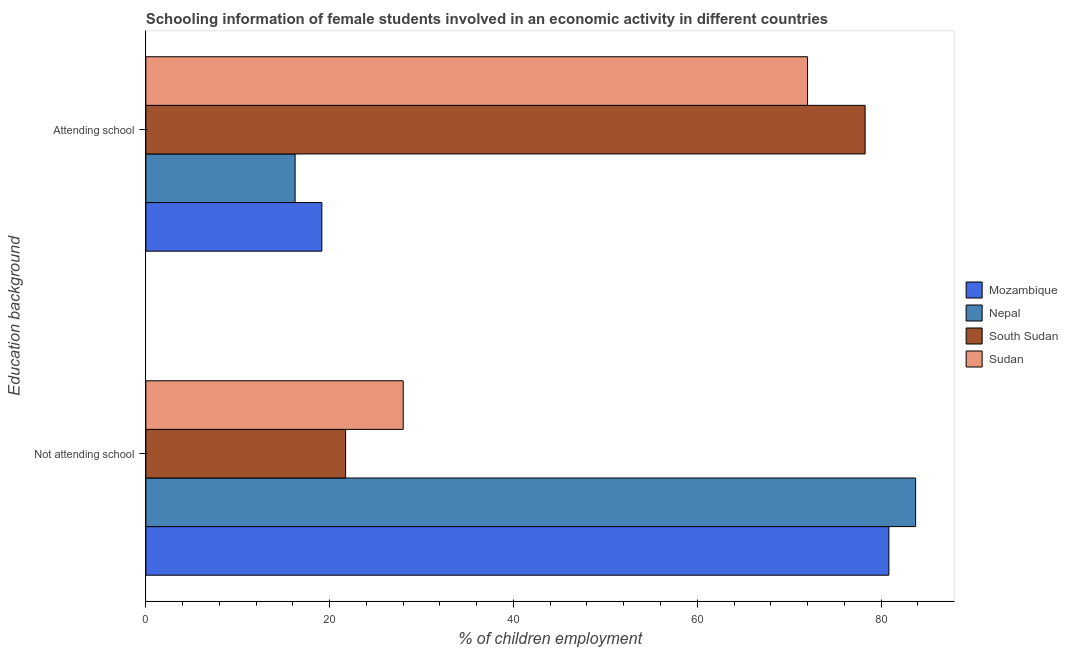How many different coloured bars are there?
Your answer should be compact. 4. How many groups of bars are there?
Keep it short and to the point. 2. Are the number of bars on each tick of the Y-axis equal?
Keep it short and to the point. Yes. How many bars are there on the 2nd tick from the bottom?
Ensure brevity in your answer.  4. What is the label of the 2nd group of bars from the top?
Provide a short and direct response. Not attending school. What is the percentage of employed females who are attending school in Mozambique?
Provide a succinct answer. 19.15. Across all countries, what is the maximum percentage of employed females who are not attending school?
Keep it short and to the point. 83.76. Across all countries, what is the minimum percentage of employed females who are not attending school?
Your answer should be compact. 21.74. In which country was the percentage of employed females who are not attending school maximum?
Offer a terse response. Nepal. In which country was the percentage of employed females who are attending school minimum?
Offer a very short reply. Nepal. What is the total percentage of employed females who are attending school in the graph?
Your answer should be compact. 185.65. What is the difference between the percentage of employed females who are attending school in Mozambique and that in Sudan?
Give a very brief answer. -52.85. What is the difference between the percentage of employed females who are not attending school in Mozambique and the percentage of employed females who are attending school in South Sudan?
Your answer should be compact. 2.59. What is the average percentage of employed females who are attending school per country?
Your answer should be compact. 46.41. What is the difference between the percentage of employed females who are attending school and percentage of employed females who are not attending school in Nepal?
Offer a terse response. -67.52. In how many countries, is the percentage of employed females who are attending school greater than 36 %?
Ensure brevity in your answer.  2. What is the ratio of the percentage of employed females who are attending school in Sudan to that in Mozambique?
Offer a very short reply. 3.76. Is the percentage of employed females who are attending school in Sudan less than that in South Sudan?
Provide a succinct answer. Yes. In how many countries, is the percentage of employed females who are attending school greater than the average percentage of employed females who are attending school taken over all countries?
Provide a short and direct response. 2. What does the 2nd bar from the top in Attending school represents?
Provide a succinct answer. South Sudan. What does the 3rd bar from the bottom in Attending school represents?
Offer a terse response. South Sudan. How many bars are there?
Offer a terse response. 8. What is the difference between two consecutive major ticks on the X-axis?
Give a very brief answer. 20. Are the values on the major ticks of X-axis written in scientific E-notation?
Your response must be concise. No. How many legend labels are there?
Offer a very short reply. 4. How are the legend labels stacked?
Ensure brevity in your answer.  Vertical. What is the title of the graph?
Your answer should be very brief. Schooling information of female students involved in an economic activity in different countries. What is the label or title of the X-axis?
Give a very brief answer. % of children employment. What is the label or title of the Y-axis?
Ensure brevity in your answer.  Education background. What is the % of children employment in Mozambique in Not attending school?
Offer a terse response. 80.85. What is the % of children employment of Nepal in Not attending school?
Provide a short and direct response. 83.76. What is the % of children employment in South Sudan in Not attending school?
Make the answer very short. 21.74. What is the % of children employment of Sudan in Not attending school?
Offer a terse response. 28. What is the % of children employment of Mozambique in Attending school?
Your response must be concise. 19.15. What is the % of children employment of Nepal in Attending school?
Ensure brevity in your answer.  16.24. What is the % of children employment of South Sudan in Attending school?
Your answer should be very brief. 78.26. What is the % of children employment of Sudan in Attending school?
Your response must be concise. 72. Across all Education background, what is the maximum % of children employment of Mozambique?
Offer a very short reply. 80.85. Across all Education background, what is the maximum % of children employment of Nepal?
Provide a short and direct response. 83.76. Across all Education background, what is the maximum % of children employment of South Sudan?
Give a very brief answer. 78.26. Across all Education background, what is the maximum % of children employment of Sudan?
Keep it short and to the point. 72. Across all Education background, what is the minimum % of children employment of Mozambique?
Give a very brief answer. 19.15. Across all Education background, what is the minimum % of children employment in Nepal?
Make the answer very short. 16.24. Across all Education background, what is the minimum % of children employment in South Sudan?
Offer a terse response. 21.74. Across all Education background, what is the minimum % of children employment of Sudan?
Give a very brief answer. 28. What is the total % of children employment of Nepal in the graph?
Your answer should be very brief. 100. What is the difference between the % of children employment of Mozambique in Not attending school and that in Attending school?
Provide a short and direct response. 61.7. What is the difference between the % of children employment of Nepal in Not attending school and that in Attending school?
Ensure brevity in your answer.  67.52. What is the difference between the % of children employment of South Sudan in Not attending school and that in Attending school?
Your response must be concise. -56.53. What is the difference between the % of children employment in Sudan in Not attending school and that in Attending school?
Keep it short and to the point. -43.99. What is the difference between the % of children employment of Mozambique in Not attending school and the % of children employment of Nepal in Attending school?
Offer a terse response. 64.61. What is the difference between the % of children employment in Mozambique in Not attending school and the % of children employment in South Sudan in Attending school?
Your answer should be very brief. 2.59. What is the difference between the % of children employment in Mozambique in Not attending school and the % of children employment in Sudan in Attending school?
Offer a terse response. 8.85. What is the difference between the % of children employment in Nepal in Not attending school and the % of children employment in South Sudan in Attending school?
Ensure brevity in your answer.  5.5. What is the difference between the % of children employment in Nepal in Not attending school and the % of children employment in Sudan in Attending school?
Provide a succinct answer. 11.76. What is the difference between the % of children employment of South Sudan in Not attending school and the % of children employment of Sudan in Attending school?
Ensure brevity in your answer.  -50.26. What is the average % of children employment of Nepal per Education background?
Your answer should be compact. 50. What is the average % of children employment in South Sudan per Education background?
Provide a short and direct response. 50. What is the difference between the % of children employment in Mozambique and % of children employment in Nepal in Not attending school?
Offer a very short reply. -2.91. What is the difference between the % of children employment in Mozambique and % of children employment in South Sudan in Not attending school?
Give a very brief answer. 59.11. What is the difference between the % of children employment of Mozambique and % of children employment of Sudan in Not attending school?
Ensure brevity in your answer.  52.85. What is the difference between the % of children employment in Nepal and % of children employment in South Sudan in Not attending school?
Provide a succinct answer. 62.02. What is the difference between the % of children employment in Nepal and % of children employment in Sudan in Not attending school?
Ensure brevity in your answer.  55.76. What is the difference between the % of children employment of South Sudan and % of children employment of Sudan in Not attending school?
Make the answer very short. -6.27. What is the difference between the % of children employment of Mozambique and % of children employment of Nepal in Attending school?
Provide a short and direct response. 2.91. What is the difference between the % of children employment of Mozambique and % of children employment of South Sudan in Attending school?
Ensure brevity in your answer.  -59.11. What is the difference between the % of children employment in Mozambique and % of children employment in Sudan in Attending school?
Keep it short and to the point. -52.85. What is the difference between the % of children employment in Nepal and % of children employment in South Sudan in Attending school?
Give a very brief answer. -62.02. What is the difference between the % of children employment of Nepal and % of children employment of Sudan in Attending school?
Your answer should be compact. -55.76. What is the difference between the % of children employment in South Sudan and % of children employment in Sudan in Attending school?
Your answer should be very brief. 6.27. What is the ratio of the % of children employment in Mozambique in Not attending school to that in Attending school?
Your response must be concise. 4.22. What is the ratio of the % of children employment of Nepal in Not attending school to that in Attending school?
Provide a succinct answer. 5.16. What is the ratio of the % of children employment of South Sudan in Not attending school to that in Attending school?
Give a very brief answer. 0.28. What is the ratio of the % of children employment of Sudan in Not attending school to that in Attending school?
Give a very brief answer. 0.39. What is the difference between the highest and the second highest % of children employment of Mozambique?
Your answer should be very brief. 61.7. What is the difference between the highest and the second highest % of children employment in Nepal?
Give a very brief answer. 67.52. What is the difference between the highest and the second highest % of children employment of South Sudan?
Ensure brevity in your answer.  56.53. What is the difference between the highest and the second highest % of children employment of Sudan?
Make the answer very short. 43.99. What is the difference between the highest and the lowest % of children employment in Mozambique?
Provide a short and direct response. 61.7. What is the difference between the highest and the lowest % of children employment in Nepal?
Your answer should be very brief. 67.52. What is the difference between the highest and the lowest % of children employment in South Sudan?
Provide a short and direct response. 56.53. What is the difference between the highest and the lowest % of children employment of Sudan?
Give a very brief answer. 43.99. 